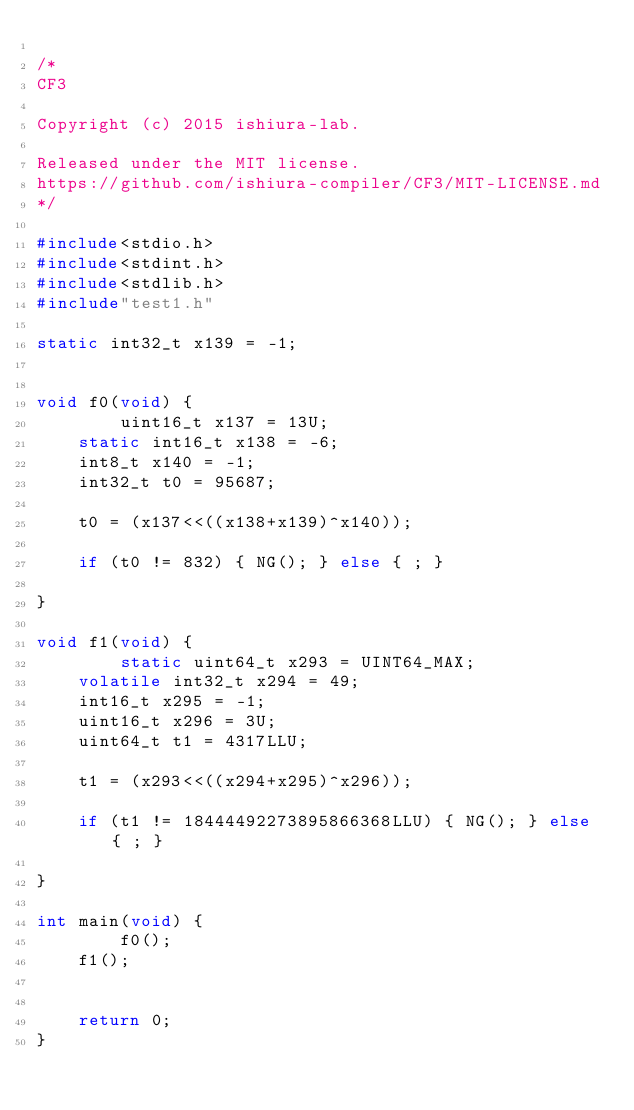<code> <loc_0><loc_0><loc_500><loc_500><_C_>
/*
CF3

Copyright (c) 2015 ishiura-lab.

Released under the MIT license.  
https://github.com/ishiura-compiler/CF3/MIT-LICENSE.md
*/

#include<stdio.h>
#include<stdint.h>
#include<stdlib.h>
#include"test1.h"

static int32_t x139 = -1;


void f0(void) {
    	uint16_t x137 = 13U;
	static int16_t x138 = -6;
	int8_t x140 = -1;
	int32_t t0 = 95687;

    t0 = (x137<<((x138+x139)^x140));

    if (t0 != 832) { NG(); } else { ; }
	
}

void f1(void) {
    	static uint64_t x293 = UINT64_MAX;
	volatile int32_t x294 = 49;
	int16_t x295 = -1;
	uint16_t x296 = 3U;
	uint64_t t1 = 4317LLU;

    t1 = (x293<<((x294+x295)^x296));

    if (t1 != 18444492273895866368LLU) { NG(); } else { ; }
	
}

int main(void) {
        f0();
    f1();


    return 0;
}

</code> 